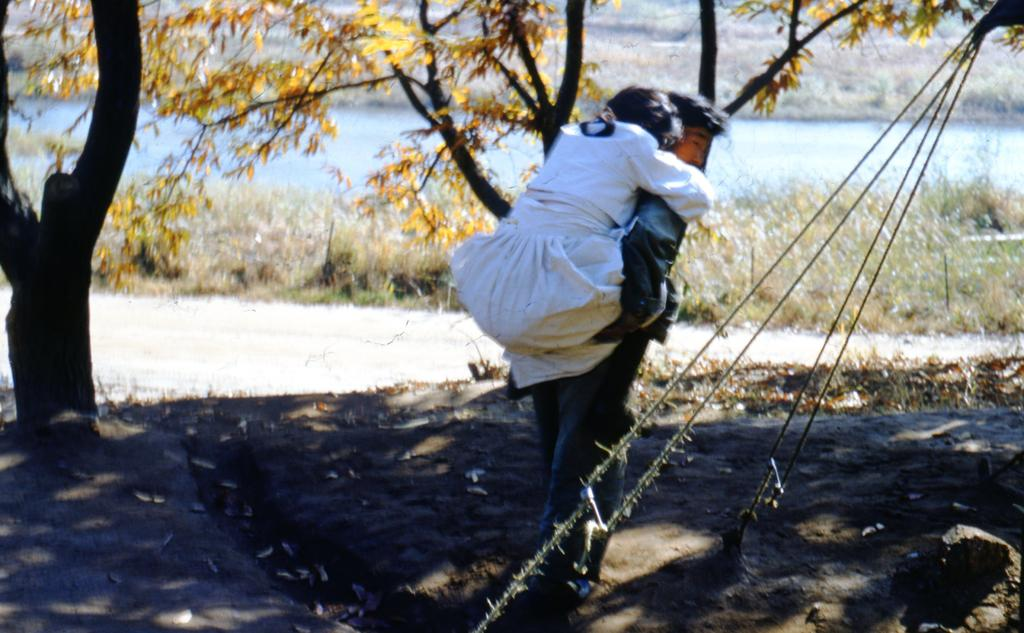What is the main action happening in the image? There is a person carrying another person on his back in the image. What type of natural environment is depicted in the image? There are trees and grass in the image. What type of cakes can be seen on the table in the image? There is no table or cakes present in the image. How many men are visible in the image? The image only shows one person carrying another person, so there is only one man visible. 